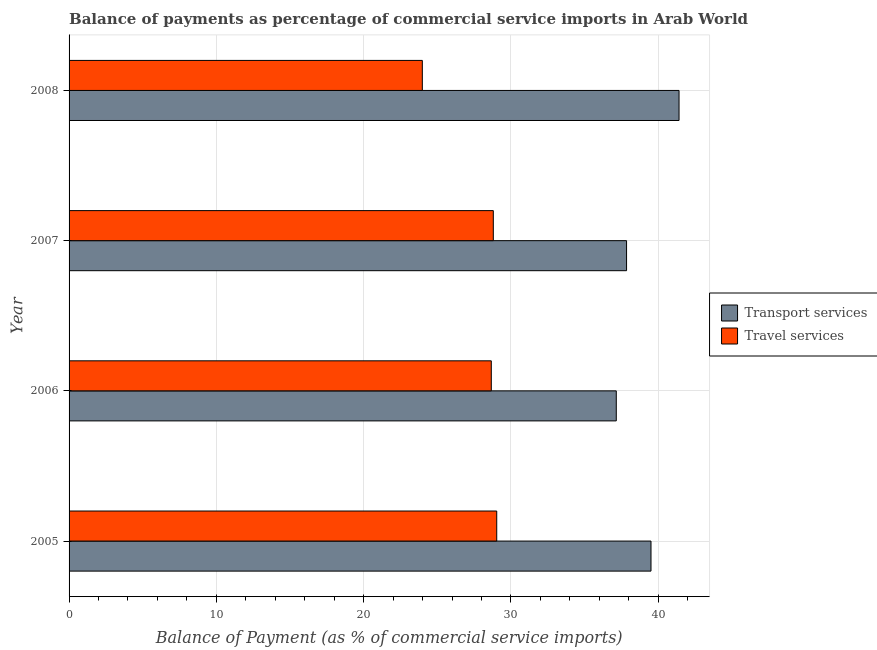How many different coloured bars are there?
Your response must be concise. 2. How many groups of bars are there?
Ensure brevity in your answer.  4. How many bars are there on the 3rd tick from the top?
Provide a short and direct response. 2. How many bars are there on the 2nd tick from the bottom?
Provide a short and direct response. 2. What is the balance of payments of transport services in 2005?
Your response must be concise. 39.51. Across all years, what is the maximum balance of payments of transport services?
Your answer should be very brief. 41.41. Across all years, what is the minimum balance of payments of transport services?
Your answer should be very brief. 37.15. In which year was the balance of payments of transport services maximum?
Provide a succinct answer. 2008. What is the total balance of payments of transport services in the graph?
Your answer should be compact. 155.92. What is the difference between the balance of payments of transport services in 2007 and that in 2008?
Ensure brevity in your answer.  -3.56. What is the difference between the balance of payments of transport services in 2006 and the balance of payments of travel services in 2007?
Provide a succinct answer. 8.35. What is the average balance of payments of transport services per year?
Offer a very short reply. 38.98. In the year 2005, what is the difference between the balance of payments of travel services and balance of payments of transport services?
Make the answer very short. -10.47. In how many years, is the balance of payments of travel services greater than 30 %?
Provide a succinct answer. 0. What is the ratio of the balance of payments of transport services in 2005 to that in 2007?
Your answer should be compact. 1.04. What is the difference between the highest and the second highest balance of payments of transport services?
Give a very brief answer. 1.9. What is the difference between the highest and the lowest balance of payments of travel services?
Make the answer very short. 5.05. In how many years, is the balance of payments of travel services greater than the average balance of payments of travel services taken over all years?
Provide a succinct answer. 3. What does the 1st bar from the top in 2006 represents?
Offer a very short reply. Travel services. What does the 1st bar from the bottom in 2005 represents?
Give a very brief answer. Transport services. How many bars are there?
Provide a short and direct response. 8. How many years are there in the graph?
Provide a succinct answer. 4. What is the difference between two consecutive major ticks on the X-axis?
Give a very brief answer. 10. Are the values on the major ticks of X-axis written in scientific E-notation?
Keep it short and to the point. No. Does the graph contain any zero values?
Provide a short and direct response. No. Does the graph contain grids?
Give a very brief answer. Yes. Where does the legend appear in the graph?
Your answer should be compact. Center right. How many legend labels are there?
Provide a succinct answer. 2. How are the legend labels stacked?
Give a very brief answer. Vertical. What is the title of the graph?
Ensure brevity in your answer.  Balance of payments as percentage of commercial service imports in Arab World. Does "Resident" appear as one of the legend labels in the graph?
Your answer should be compact. No. What is the label or title of the X-axis?
Provide a short and direct response. Balance of Payment (as % of commercial service imports). What is the label or title of the Y-axis?
Your response must be concise. Year. What is the Balance of Payment (as % of commercial service imports) in Transport services in 2005?
Make the answer very short. 39.51. What is the Balance of Payment (as % of commercial service imports) of Travel services in 2005?
Your answer should be compact. 29.03. What is the Balance of Payment (as % of commercial service imports) of Transport services in 2006?
Keep it short and to the point. 37.15. What is the Balance of Payment (as % of commercial service imports) in Travel services in 2006?
Your answer should be very brief. 28.66. What is the Balance of Payment (as % of commercial service imports) of Transport services in 2007?
Make the answer very short. 37.85. What is the Balance of Payment (as % of commercial service imports) of Travel services in 2007?
Offer a very short reply. 28.8. What is the Balance of Payment (as % of commercial service imports) in Transport services in 2008?
Offer a terse response. 41.41. What is the Balance of Payment (as % of commercial service imports) of Travel services in 2008?
Provide a short and direct response. 23.98. Across all years, what is the maximum Balance of Payment (as % of commercial service imports) of Transport services?
Offer a very short reply. 41.41. Across all years, what is the maximum Balance of Payment (as % of commercial service imports) of Travel services?
Ensure brevity in your answer.  29.03. Across all years, what is the minimum Balance of Payment (as % of commercial service imports) of Transport services?
Your answer should be very brief. 37.15. Across all years, what is the minimum Balance of Payment (as % of commercial service imports) in Travel services?
Offer a terse response. 23.98. What is the total Balance of Payment (as % of commercial service imports) of Transport services in the graph?
Give a very brief answer. 155.92. What is the total Balance of Payment (as % of commercial service imports) in Travel services in the graph?
Make the answer very short. 110.48. What is the difference between the Balance of Payment (as % of commercial service imports) in Transport services in 2005 and that in 2006?
Give a very brief answer. 2.36. What is the difference between the Balance of Payment (as % of commercial service imports) in Travel services in 2005 and that in 2006?
Your response must be concise. 0.37. What is the difference between the Balance of Payment (as % of commercial service imports) in Transport services in 2005 and that in 2007?
Offer a very short reply. 1.66. What is the difference between the Balance of Payment (as % of commercial service imports) in Travel services in 2005 and that in 2007?
Give a very brief answer. 0.23. What is the difference between the Balance of Payment (as % of commercial service imports) in Transport services in 2005 and that in 2008?
Provide a succinct answer. -1.9. What is the difference between the Balance of Payment (as % of commercial service imports) of Travel services in 2005 and that in 2008?
Your answer should be very brief. 5.05. What is the difference between the Balance of Payment (as % of commercial service imports) in Transport services in 2006 and that in 2007?
Offer a terse response. -0.7. What is the difference between the Balance of Payment (as % of commercial service imports) of Travel services in 2006 and that in 2007?
Provide a short and direct response. -0.14. What is the difference between the Balance of Payment (as % of commercial service imports) in Transport services in 2006 and that in 2008?
Offer a terse response. -4.26. What is the difference between the Balance of Payment (as % of commercial service imports) of Travel services in 2006 and that in 2008?
Your response must be concise. 4.68. What is the difference between the Balance of Payment (as % of commercial service imports) in Transport services in 2007 and that in 2008?
Provide a short and direct response. -3.56. What is the difference between the Balance of Payment (as % of commercial service imports) in Travel services in 2007 and that in 2008?
Offer a terse response. 4.82. What is the difference between the Balance of Payment (as % of commercial service imports) in Transport services in 2005 and the Balance of Payment (as % of commercial service imports) in Travel services in 2006?
Keep it short and to the point. 10.84. What is the difference between the Balance of Payment (as % of commercial service imports) in Transport services in 2005 and the Balance of Payment (as % of commercial service imports) in Travel services in 2007?
Provide a succinct answer. 10.71. What is the difference between the Balance of Payment (as % of commercial service imports) of Transport services in 2005 and the Balance of Payment (as % of commercial service imports) of Travel services in 2008?
Give a very brief answer. 15.52. What is the difference between the Balance of Payment (as % of commercial service imports) in Transport services in 2006 and the Balance of Payment (as % of commercial service imports) in Travel services in 2007?
Ensure brevity in your answer.  8.35. What is the difference between the Balance of Payment (as % of commercial service imports) of Transport services in 2006 and the Balance of Payment (as % of commercial service imports) of Travel services in 2008?
Provide a succinct answer. 13.17. What is the difference between the Balance of Payment (as % of commercial service imports) of Transport services in 2007 and the Balance of Payment (as % of commercial service imports) of Travel services in 2008?
Provide a short and direct response. 13.86. What is the average Balance of Payment (as % of commercial service imports) of Transport services per year?
Offer a very short reply. 38.98. What is the average Balance of Payment (as % of commercial service imports) of Travel services per year?
Provide a short and direct response. 27.62. In the year 2005, what is the difference between the Balance of Payment (as % of commercial service imports) of Transport services and Balance of Payment (as % of commercial service imports) of Travel services?
Provide a succinct answer. 10.47. In the year 2006, what is the difference between the Balance of Payment (as % of commercial service imports) in Transport services and Balance of Payment (as % of commercial service imports) in Travel services?
Your answer should be compact. 8.49. In the year 2007, what is the difference between the Balance of Payment (as % of commercial service imports) of Transport services and Balance of Payment (as % of commercial service imports) of Travel services?
Offer a very short reply. 9.05. In the year 2008, what is the difference between the Balance of Payment (as % of commercial service imports) of Transport services and Balance of Payment (as % of commercial service imports) of Travel services?
Keep it short and to the point. 17.43. What is the ratio of the Balance of Payment (as % of commercial service imports) in Transport services in 2005 to that in 2006?
Make the answer very short. 1.06. What is the ratio of the Balance of Payment (as % of commercial service imports) of Travel services in 2005 to that in 2006?
Keep it short and to the point. 1.01. What is the ratio of the Balance of Payment (as % of commercial service imports) of Transport services in 2005 to that in 2007?
Provide a short and direct response. 1.04. What is the ratio of the Balance of Payment (as % of commercial service imports) of Transport services in 2005 to that in 2008?
Offer a terse response. 0.95. What is the ratio of the Balance of Payment (as % of commercial service imports) of Travel services in 2005 to that in 2008?
Ensure brevity in your answer.  1.21. What is the ratio of the Balance of Payment (as % of commercial service imports) of Transport services in 2006 to that in 2007?
Provide a short and direct response. 0.98. What is the ratio of the Balance of Payment (as % of commercial service imports) in Travel services in 2006 to that in 2007?
Provide a succinct answer. 1. What is the ratio of the Balance of Payment (as % of commercial service imports) of Transport services in 2006 to that in 2008?
Your answer should be compact. 0.9. What is the ratio of the Balance of Payment (as % of commercial service imports) of Travel services in 2006 to that in 2008?
Ensure brevity in your answer.  1.2. What is the ratio of the Balance of Payment (as % of commercial service imports) in Transport services in 2007 to that in 2008?
Your answer should be very brief. 0.91. What is the ratio of the Balance of Payment (as % of commercial service imports) in Travel services in 2007 to that in 2008?
Keep it short and to the point. 1.2. What is the difference between the highest and the second highest Balance of Payment (as % of commercial service imports) in Transport services?
Make the answer very short. 1.9. What is the difference between the highest and the second highest Balance of Payment (as % of commercial service imports) of Travel services?
Make the answer very short. 0.23. What is the difference between the highest and the lowest Balance of Payment (as % of commercial service imports) in Transport services?
Keep it short and to the point. 4.26. What is the difference between the highest and the lowest Balance of Payment (as % of commercial service imports) of Travel services?
Your answer should be very brief. 5.05. 